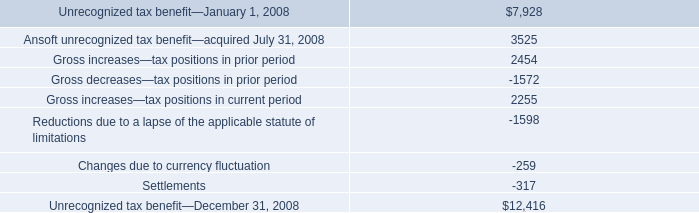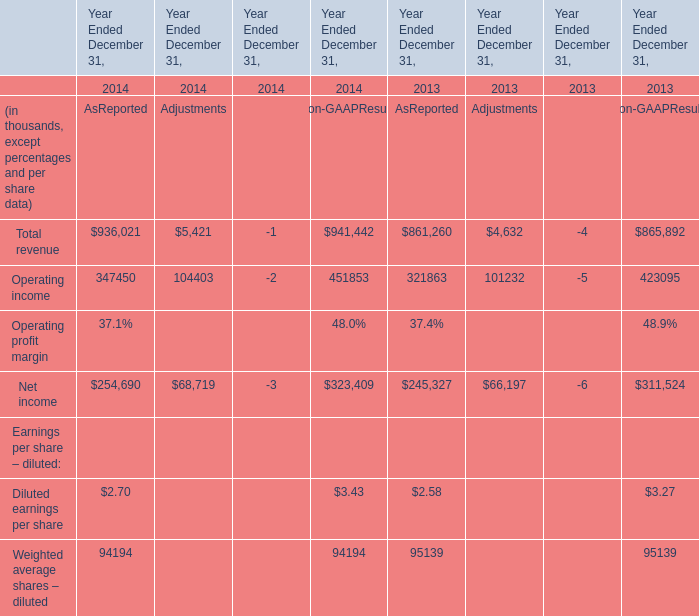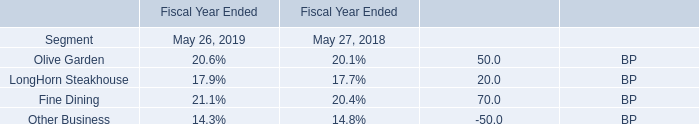what's the total amount of Operating income of Year Ended December 31, 2013 Adjustments, and Unrecognized tax benefit—December 31, 2008 ? 
Computations: (101232.0 + 12416.0)
Answer: 113648.0. 